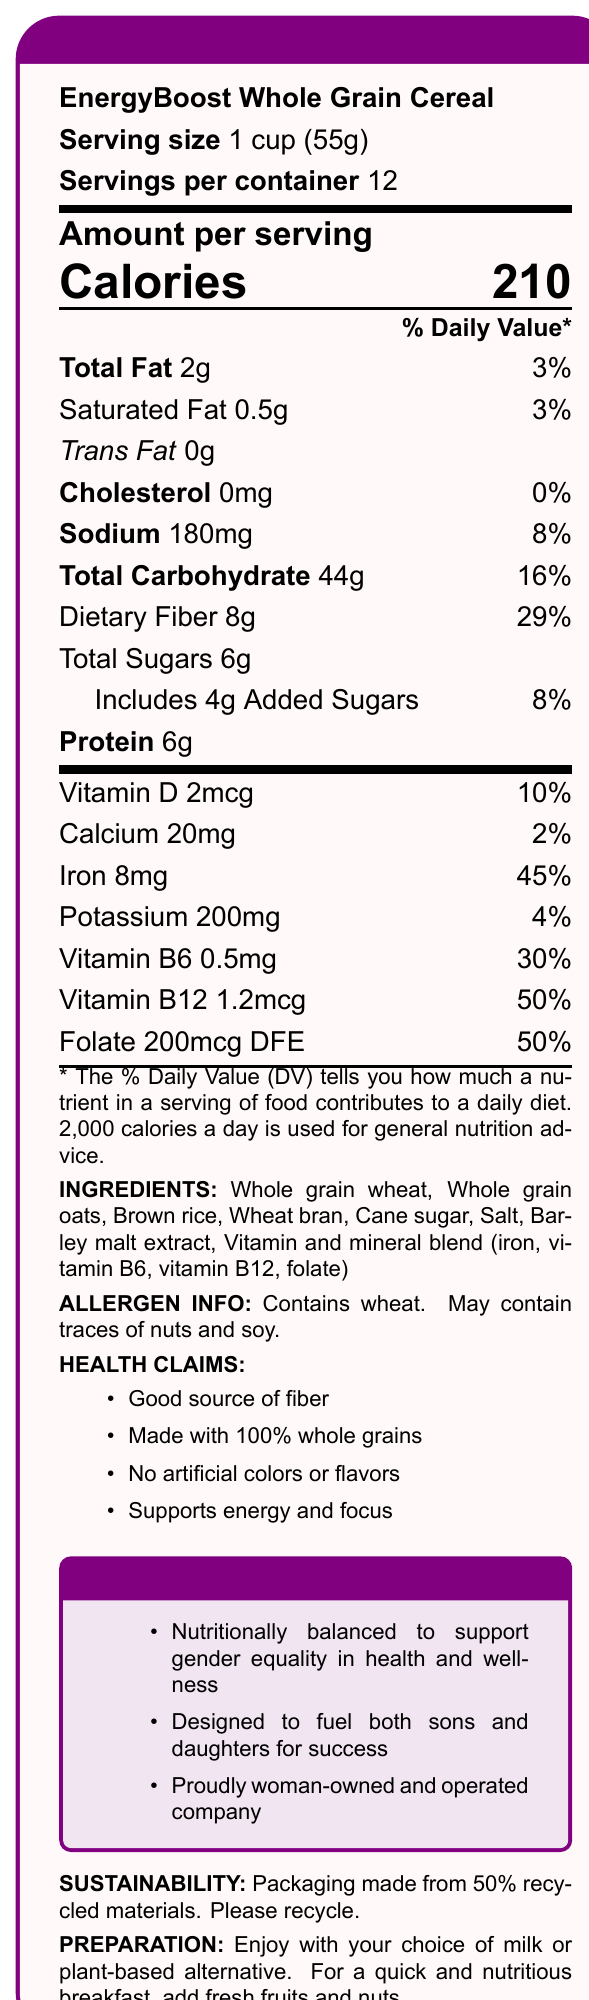what is the serving size for EnergyBoost Whole Grain Cereal? The document specifies that the serving size is 1 cup (55g).
Answer: 1 cup (55g) how many calories are there per serving? The document states that there are 210 calories per serving.
Answer: 210 how much dietary fiber is in one serving of the cereal? The document lists 8g of dietary fiber per serving.
Answer: 8g what percentage of the daily value for iron does one serving provide? The document shows that one serving provides 45% of the daily value for iron.
Answer: 45% what vitamins are included in the vitamin and mineral blend? The document lists iron, vitamin B6, vitamin B12, and folate in the vitamin and mineral blend.
Answer: Iron, vitamin B6, vitamin B12, folate which health claim is NOT made about this cereal? A. Supports energy and focus B. Good source of protein C. No artificial colors or flavors The document mentions that the cereal is a good source of fiber, supports energy and focus, and has no artificial colors or flavors, but it does not claim to be a good source of protein.
Answer: B. Good source of protein how many grams of added sugars are in one serving? The document specifies that there are 4g of added sugars in one serving.
Answer: 4g is EnergyBoost Whole Grain Cereal free of any cholesterol? The document shows that the cereal contains 0mg of cholesterol, indicating it is free of cholesterol.
Answer: Yes what allergens are mentioned in the document? The document provides allergen information, stating that the cereal contains wheat and may contain traces of nuts and soy.
Answer: Wheat, may contain traces of nuts and soy what is the main idea of this document? The document is centered around providing detailed nutritional information, ingredients, health claims, and additional marketing points for the cereal.
Answer: This document provides the nutrition facts and additional information about EnergyBoost Whole Grain Cereal, including its nutritional content, ingredients, health claims, feminist marketing points, sustainability, and preparation instructions. are the preparation instructions clear on whether the cereal can be consumed with plant-based milk alternatives? The preparation instructions explicitly mention enjoying the cereal with milk or plant-based alternatives.
Answer: Yes what is the source of the cereal's sweetness according to the ingredients? The ingredients list specifies that cane sugar and barley malt extract are sources of sweetness in the cereal.
Answer: Cane sugar, Barley malt extract how many servings are there per container? The document indicates that each container has 12 servings.
Answer: 12 which vitamin has the highest daily value percentage per serving? A. Vitamin D B. Vitamin B6 C. Folate D. Vitamin B12 The document lists Vitamin B6 as providing 30% of the daily value, Folate at 50%, Vitamin D at 10%, and Vitamin B12 at 50%. Folate and Vitamin B12 are tied, but only Vitamin B12 is listed as an option here.
Answer: D. Vitamin B12 how much calcium does one serving provide, and what is the daily value percentage? The document indicates one serving provides 20mg of calcium, accounting for 2% of the daily value.
Answer: 20mg, 2% is the cereal free from artificial colors and flavors? The document includes a health claim stating that the cereal has no artificial colors or flavors.
Answer: Yes will consuming one serving provide a complete daily requirement of iron? One serving provides 45% of the daily value for iron, which is less than 100% of the daily requirement.
Answer: No who owns and operates the company producing this cereal? The document states that the company is proudly woman-owned and operated.
Answer: A woman-owned and operated company what is the total amount of dietary fiber from consuming the entire container? There are 8g of dietary fiber per serving and 12 servings per container, so 8g x 12 = 96g.
Answer: 96g is the cereal a good choice for those who need low sodium? The document indicates the sodium content as 180mg per serving, accounting for 8% of the daily value, which might be considered high for a low-sodium diet.
Answer: No what is the company’s stance on sustainability? The document states that the packaging is made from 50% recycled materials and encourages recycling.
Answer: Packaging made from 50% recycled materials. Please recycle. what is the price of this cereal? The document does not provide any information regarding the price of the cereal.
Answer: Not enough information 